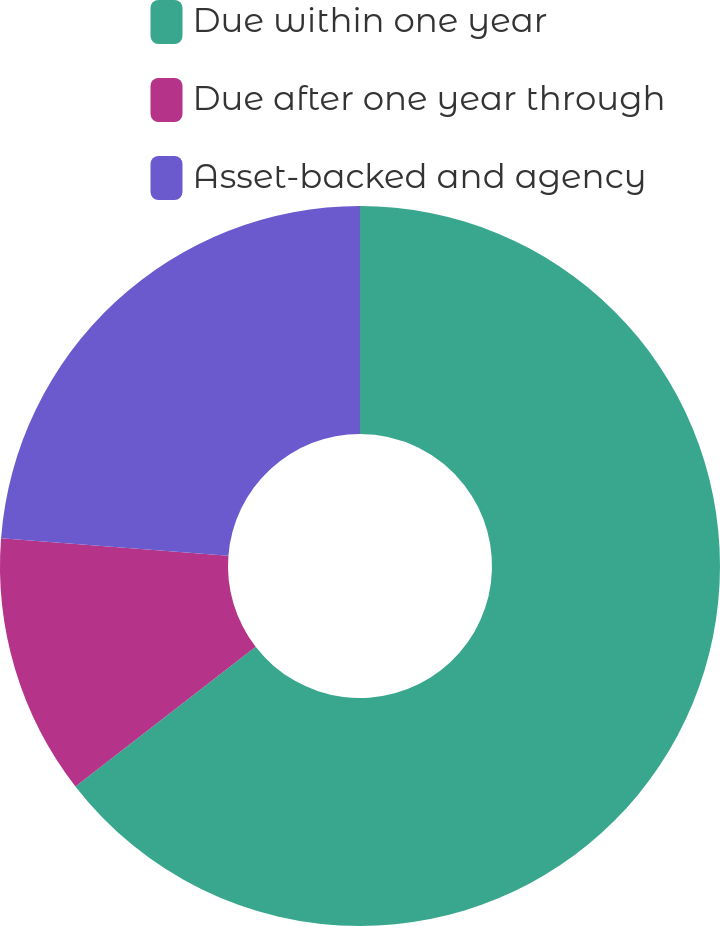Convert chart. <chart><loc_0><loc_0><loc_500><loc_500><pie_chart><fcel>Due within one year<fcel>Due after one year through<fcel>Asset-backed and agency<nl><fcel>64.51%<fcel>11.72%<fcel>23.77%<nl></chart> 